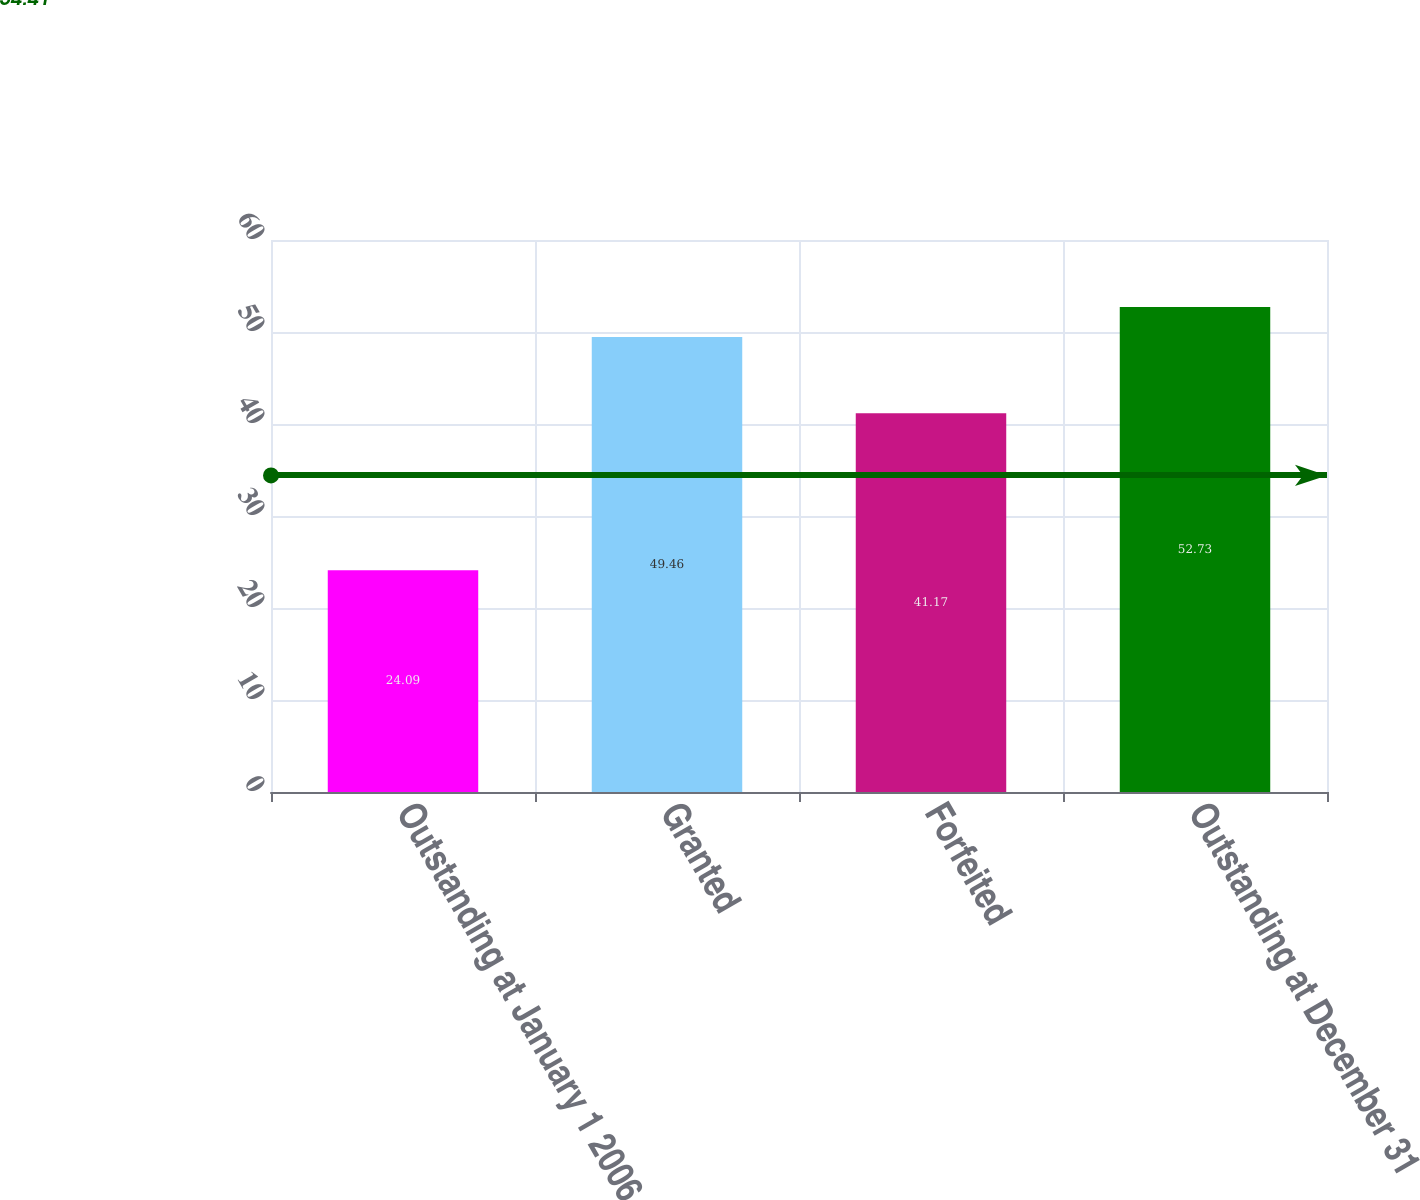Convert chart. <chart><loc_0><loc_0><loc_500><loc_500><bar_chart><fcel>Outstanding at January 1 2006<fcel>Granted<fcel>Forfeited<fcel>Outstanding at December 31<nl><fcel>24.09<fcel>49.46<fcel>41.17<fcel>52.73<nl></chart> 